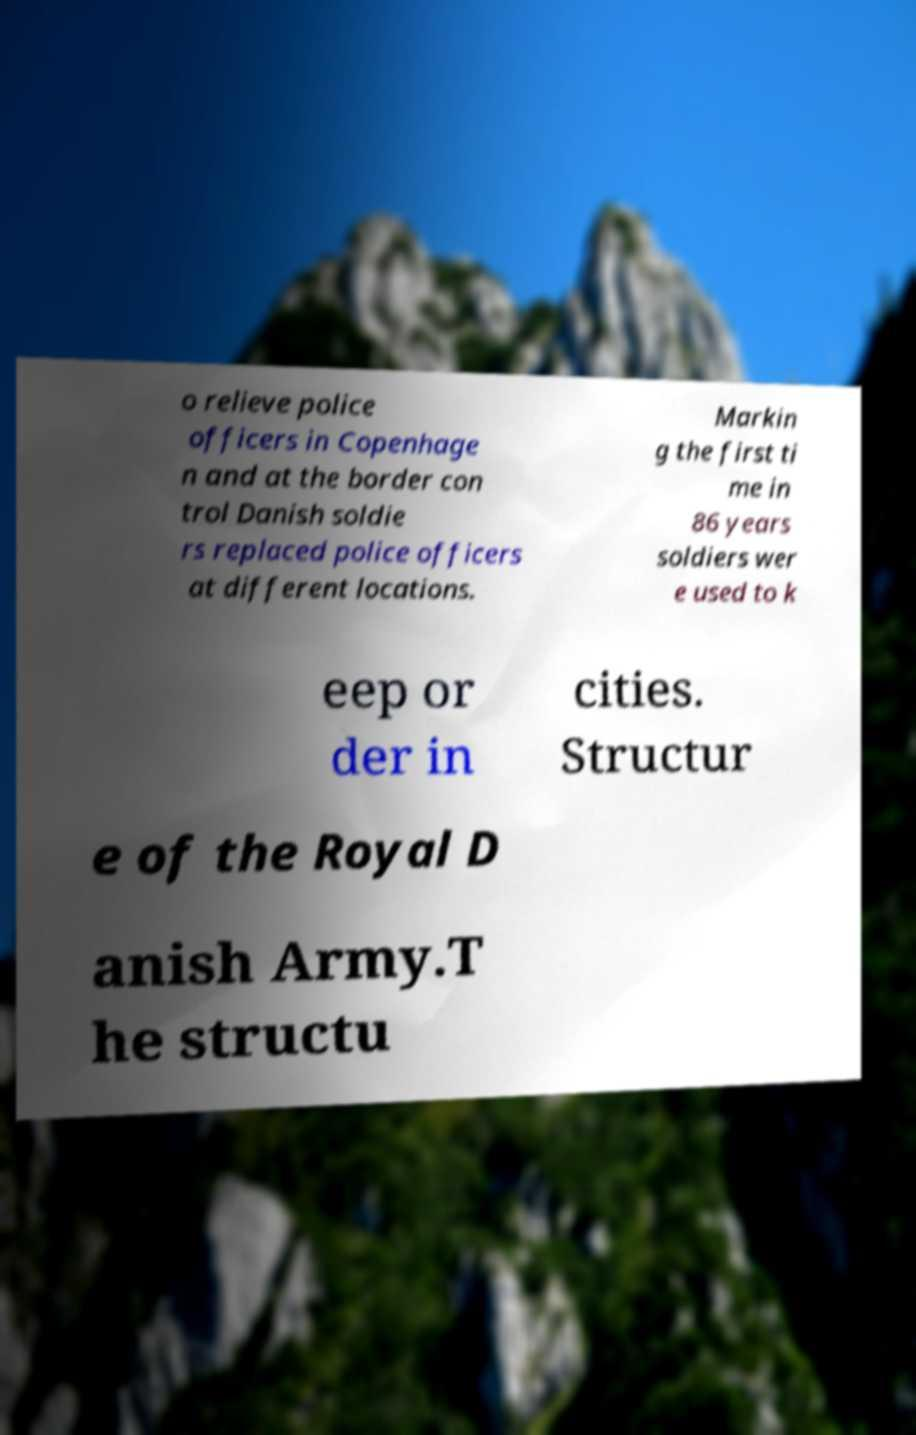Please read and relay the text visible in this image. What does it say? o relieve police officers in Copenhage n and at the border con trol Danish soldie rs replaced police officers at different locations. Markin g the first ti me in 86 years soldiers wer e used to k eep or der in cities. Structur e of the Royal D anish Army.T he structu 